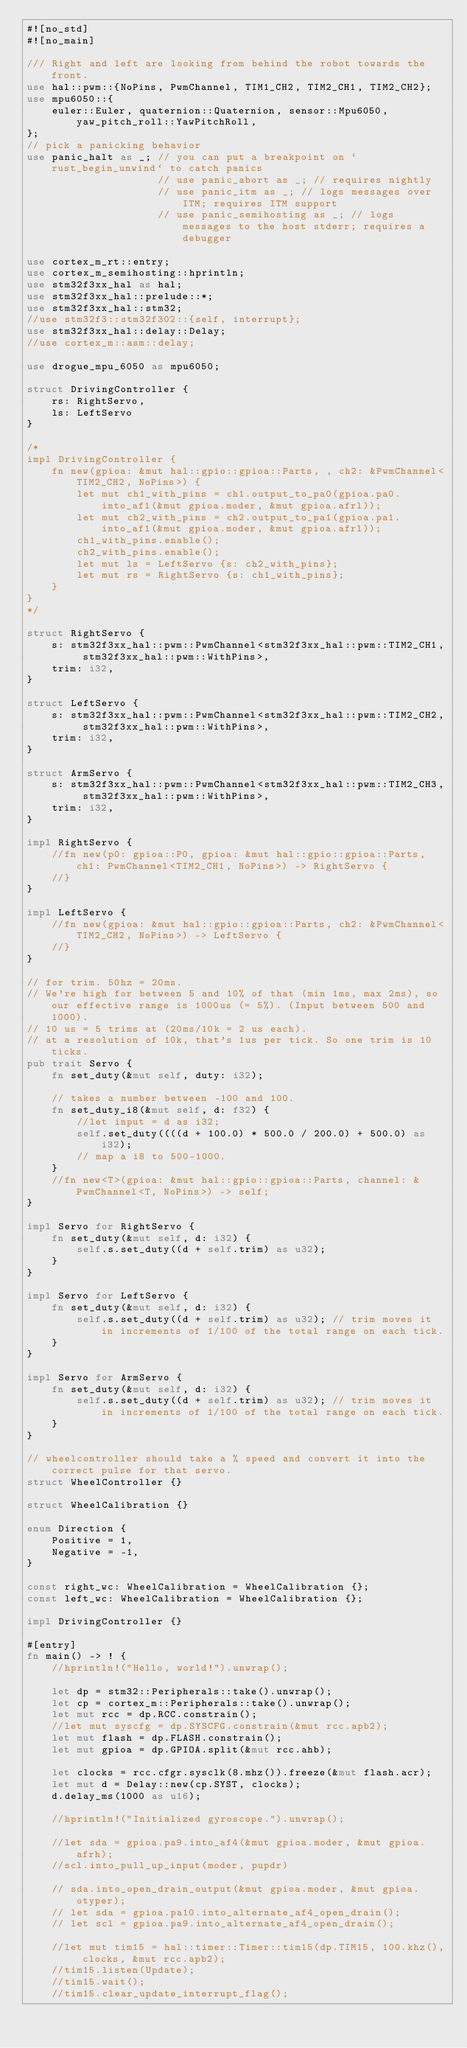<code> <loc_0><loc_0><loc_500><loc_500><_Rust_>#![no_std]
#![no_main]

/// Right and left are looking from behind the robot towards the front.
use hal::pwm::{NoPins, PwmChannel, TIM1_CH2, TIM2_CH1, TIM2_CH2};
use mpu6050::{
    euler::Euler, quaternion::Quaternion, sensor::Mpu6050, yaw_pitch_roll::YawPitchRoll,
};
// pick a panicking behavior
use panic_halt as _; // you can put a breakpoint on `rust_begin_unwind` to catch panics
                     // use panic_abort as _; // requires nightly
                     // use panic_itm as _; // logs messages over ITM; requires ITM support
                     // use panic_semihosting as _; // logs messages to the host stderr; requires a debugger

use cortex_m_rt::entry;
use cortex_m_semihosting::hprintln;
use stm32f3xx_hal as hal;
use stm32f3xx_hal::prelude::*;
use stm32f3xx_hal::stm32;
//use stm32f3::stm32f302::{self, interrupt};
use stm32f3xx_hal::delay::Delay;
//use cortex_m::asm::delay;

use drogue_mpu_6050 as mpu6050;

struct DrivingController {
    rs: RightServo,
    ls: LeftServo
}

/*
impl DrivingController {
    fn new(gpioa: &mut hal::gpio::gpioa::Parts, , ch2: &PwmChannel<TIM2_CH2, NoPins>) {
        let mut ch1_with_pins = ch1.output_to_pa0(gpioa.pa0.into_af1(&mut gpioa.moder, &mut gpioa.afrl));
        let mut ch2_with_pins = ch2.output_to_pa1(gpioa.pa1.into_af1(&mut gpioa.moder, &mut gpioa.afrl));
        ch1_with_pins.enable();
        ch2_with_pins.enable();
        let mut ls = LeftServo {s: ch2_with_pins};
        let mut rs = RightServo {s: ch1_with_pins};
    }
}
*/

struct RightServo {
    s: stm32f3xx_hal::pwm::PwmChannel<stm32f3xx_hal::pwm::TIM2_CH1, stm32f3xx_hal::pwm::WithPins>,
    trim: i32,
}

struct LeftServo {
    s: stm32f3xx_hal::pwm::PwmChannel<stm32f3xx_hal::pwm::TIM2_CH2, stm32f3xx_hal::pwm::WithPins>,
    trim: i32,
}

struct ArmServo {
    s: stm32f3xx_hal::pwm::PwmChannel<stm32f3xx_hal::pwm::TIM2_CH3, stm32f3xx_hal::pwm::WithPins>,
    trim: i32,
}

impl RightServo {
    //fn new(p0: gpioa::P0, gpioa: &mut hal::gpio::gpioa::Parts, ch1: PwmChannel<TIM2_CH1, NoPins>) -> RightServo {
    //}
}

impl LeftServo {
    //fn new(gpioa: &mut hal::gpio::gpioa::Parts, ch2: &PwmChannel<TIM2_CH2, NoPins>) -> LeftServo {
    //}
}

// for trim. 50hz = 20ms.
// We're high for between 5 and 10% of that (min 1ms, max 2ms), so our effective range is 1000us (= 5%). (Input between 500 and 1000).
// 10 us = 5 trims at (20ms/10k = 2 us each).
// at a resolution of 10k, that's 1us per tick. So one trim is 10 ticks.
pub trait Servo {
    fn set_duty(&mut self, duty: i32);

    // takes a number between -100 and 100.
    fn set_duty_i8(&mut self, d: f32) {
        //let input = d as i32;
        self.set_duty((((d + 100.0) * 500.0 / 200.0) + 500.0) as i32);
        // map a i8 to 500-1000.
    }
    //fn new<T>(gpioa: &mut hal::gpio::gpioa::Parts, channel: &PwmChannel<T, NoPins>) -> self;
}

impl Servo for RightServo {
    fn set_duty(&mut self, d: i32) {
        self.s.set_duty((d + self.trim) as u32);
    }
}

impl Servo for LeftServo {
    fn set_duty(&mut self, d: i32) {
        self.s.set_duty((d + self.trim) as u32); // trim moves it in increments of 1/100 of the total range on each tick.
    }
}

impl Servo for ArmServo {
    fn set_duty(&mut self, d: i32) {
        self.s.set_duty((d + self.trim) as u32); // trim moves it in increments of 1/100 of the total range on each tick.
    }
}

// wheelcontroller should take a % speed and convert it into the correct pulse for that servo.
struct WheelController {}

struct WheelCalibration {}

enum Direction {
    Positive = 1,
    Negative = -1,
}

const right_wc: WheelCalibration = WheelCalibration {};
const left_wc: WheelCalibration = WheelCalibration {};

impl DrivingController {}

#[entry]
fn main() -> ! {
    //hprintln!("Hello, world!").unwrap();

    let dp = stm32::Peripherals::take().unwrap();
    let cp = cortex_m::Peripherals::take().unwrap();
    let mut rcc = dp.RCC.constrain();
    //let mut syscfg = dp.SYSCFG.constrain(&mut rcc.apb2);
    let mut flash = dp.FLASH.constrain();
    let mut gpioa = dp.GPIOA.split(&mut rcc.ahb);

    let clocks = rcc.cfgr.sysclk(8.mhz()).freeze(&mut flash.acr);
    let mut d = Delay::new(cp.SYST, clocks);
    d.delay_ms(1000 as u16);

    //hprintln!("Initialized gyroscope.").unwrap();

    //let sda = gpioa.pa9.into_af4(&mut gpioa.moder, &mut gpioa.afrh);
    //scl.into_pull_up_input(moder, pupdr)

    // sda.into_open_drain_output(&mut gpioa.moder, &mut gpioa.otyper);
    // let sda = gpioa.pa10.into_alternate_af4_open_drain();
    // let scl = gpioa.pa9.into_alternate_af4_open_drain();

    //let mut tim15 = hal::timer::Timer::tim15(dp.TIM15, 100.khz(), clocks, &mut rcc.apb2);
    //tim15.listen(Update);
    //tim15.wait();
    //tim15.clear_update_interrupt_flag();
</code> 